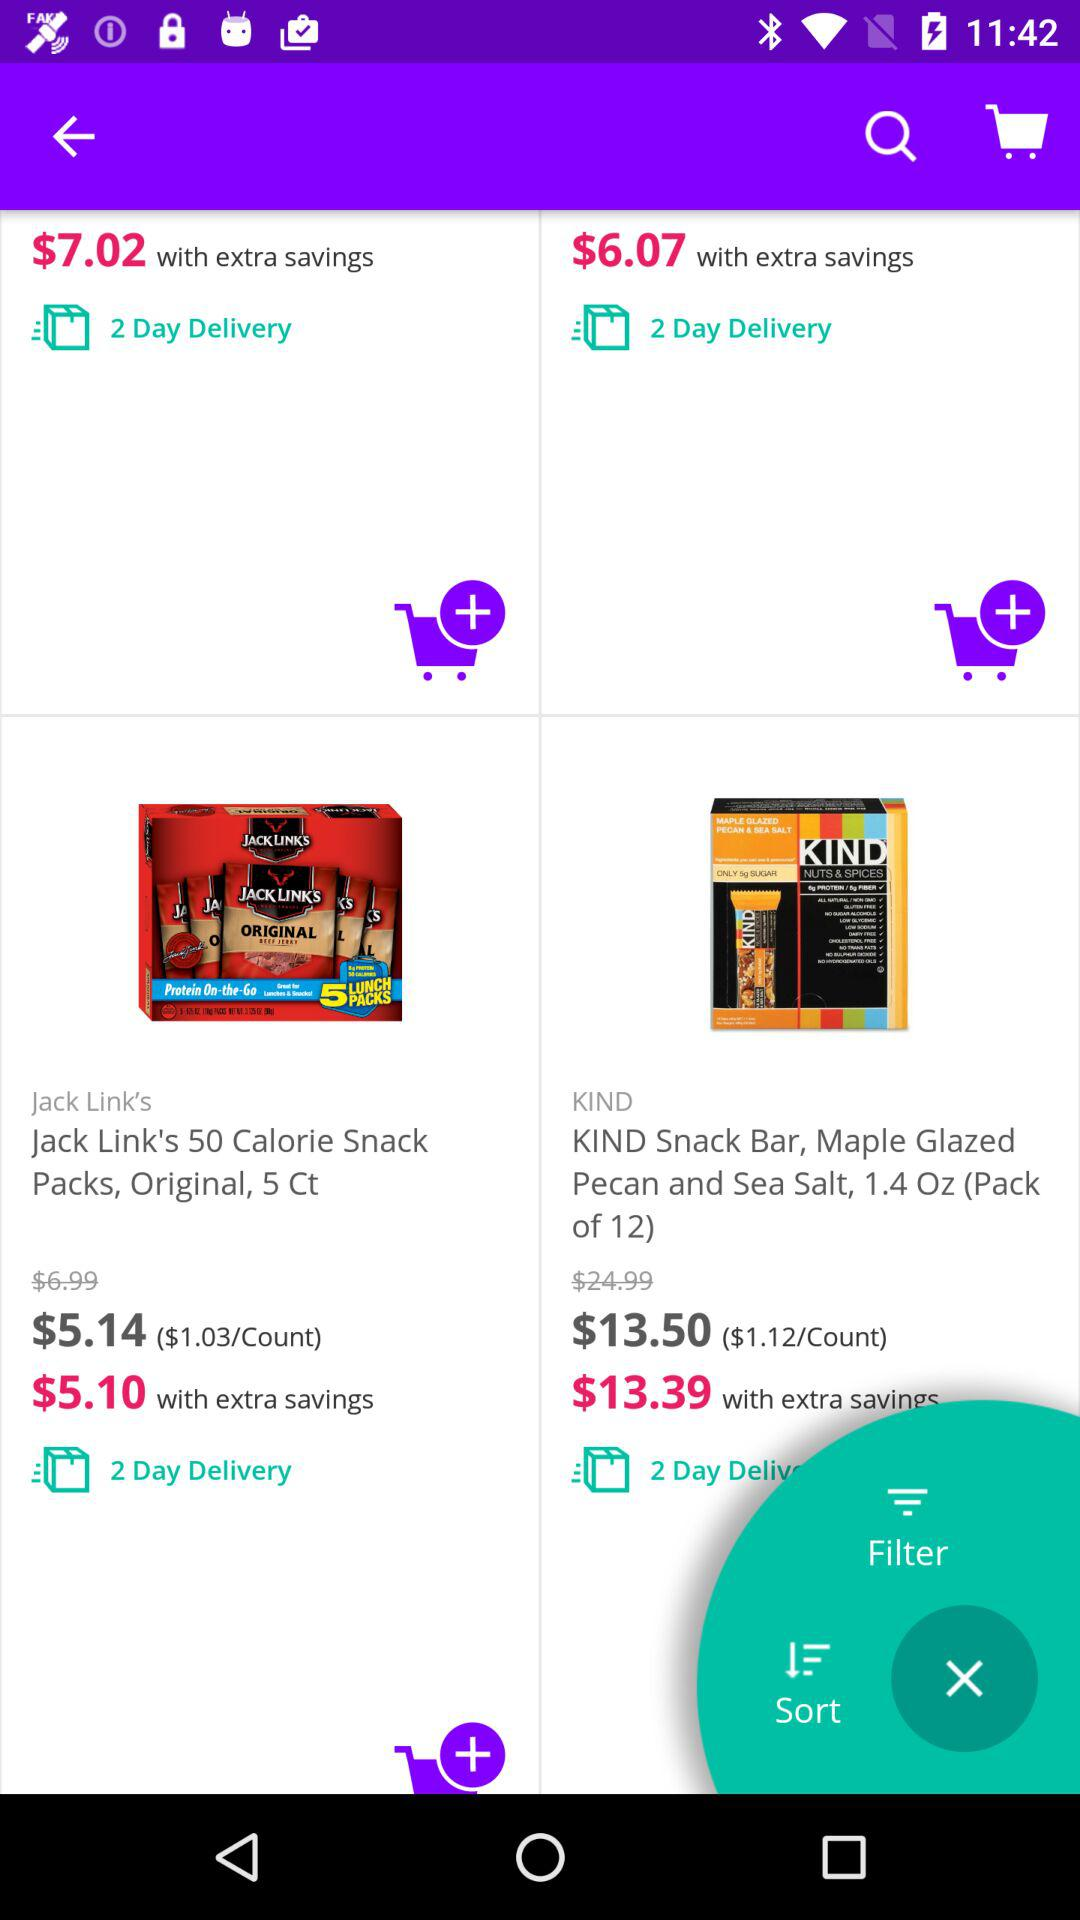In how many days can "Jack Link's 50 Calorie Snack Packs" be delivered? The snack can be delivered in 2 days. 